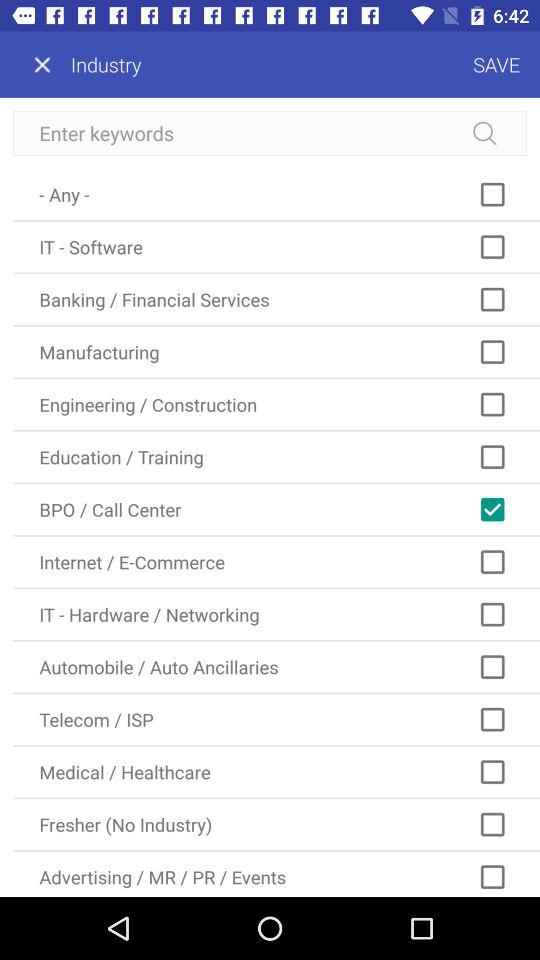How many industries can the user filter by?
Answer the question using a single word or phrase. 13 